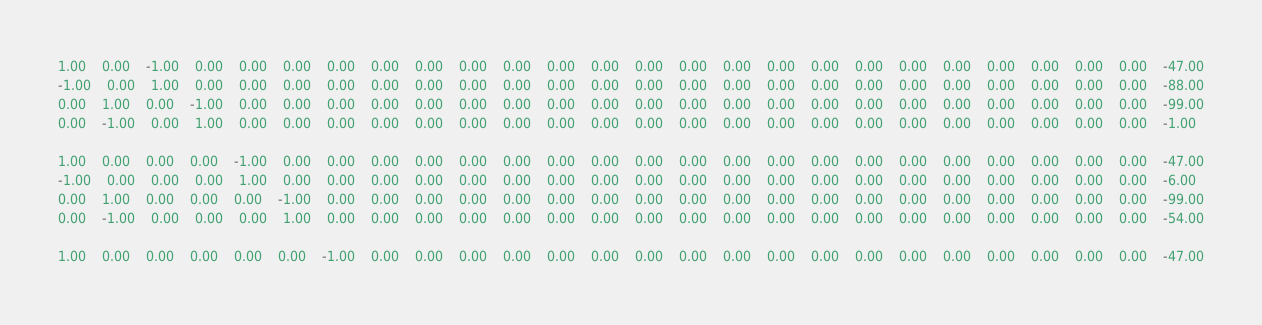Convert code to text. <code><loc_0><loc_0><loc_500><loc_500><_Matlab_>1.00	0.00	-1.00	0.00	0.00	0.00	0.00	0.00	0.00	0.00	0.00	0.00	0.00	0.00	0.00	0.00	0.00	0.00	0.00	0.00	0.00	0.00	0.00	0.00	0.00	-47.00
-1.00	0.00	1.00	0.00	0.00	0.00	0.00	0.00	0.00	0.00	0.00	0.00	0.00	0.00	0.00	0.00	0.00	0.00	0.00	0.00	0.00	0.00	0.00	0.00	0.00	-88.00
0.00	1.00	0.00	-1.00	0.00	0.00	0.00	0.00	0.00	0.00	0.00	0.00	0.00	0.00	0.00	0.00	0.00	0.00	0.00	0.00	0.00	0.00	0.00	0.00	0.00	-99.00
0.00	-1.00	0.00	1.00	0.00	0.00	0.00	0.00	0.00	0.00	0.00	0.00	0.00	0.00	0.00	0.00	0.00	0.00	0.00	0.00	0.00	0.00	0.00	0.00	0.00	-1.00

1.00	0.00	0.00	0.00	-1.00	0.00	0.00	0.00	0.00	0.00	0.00	0.00	0.00	0.00	0.00	0.00	0.00	0.00	0.00	0.00	0.00	0.00	0.00	0.00	0.00	-47.00
-1.00	0.00	0.00	0.00	1.00	0.00	0.00	0.00	0.00	0.00	0.00	0.00	0.00	0.00	0.00	0.00	0.00	0.00	0.00	0.00	0.00	0.00	0.00	0.00	0.00	-6.00
0.00	1.00	0.00	0.00	0.00	-1.00	0.00	0.00	0.00	0.00	0.00	0.00	0.00	0.00	0.00	0.00	0.00	0.00	0.00	0.00	0.00	0.00	0.00	0.00	0.00	-99.00
0.00	-1.00	0.00	0.00	0.00	1.00	0.00	0.00	0.00	0.00	0.00	0.00	0.00	0.00	0.00	0.00	0.00	0.00	0.00	0.00	0.00	0.00	0.00	0.00	0.00	-54.00

1.00	0.00	0.00	0.00	0.00	0.00	-1.00	0.00	0.00	0.00	0.00	0.00	0.00	0.00	0.00	0.00	0.00	0.00	0.00	0.00	0.00	0.00	0.00	0.00	0.00	-47.00</code> 